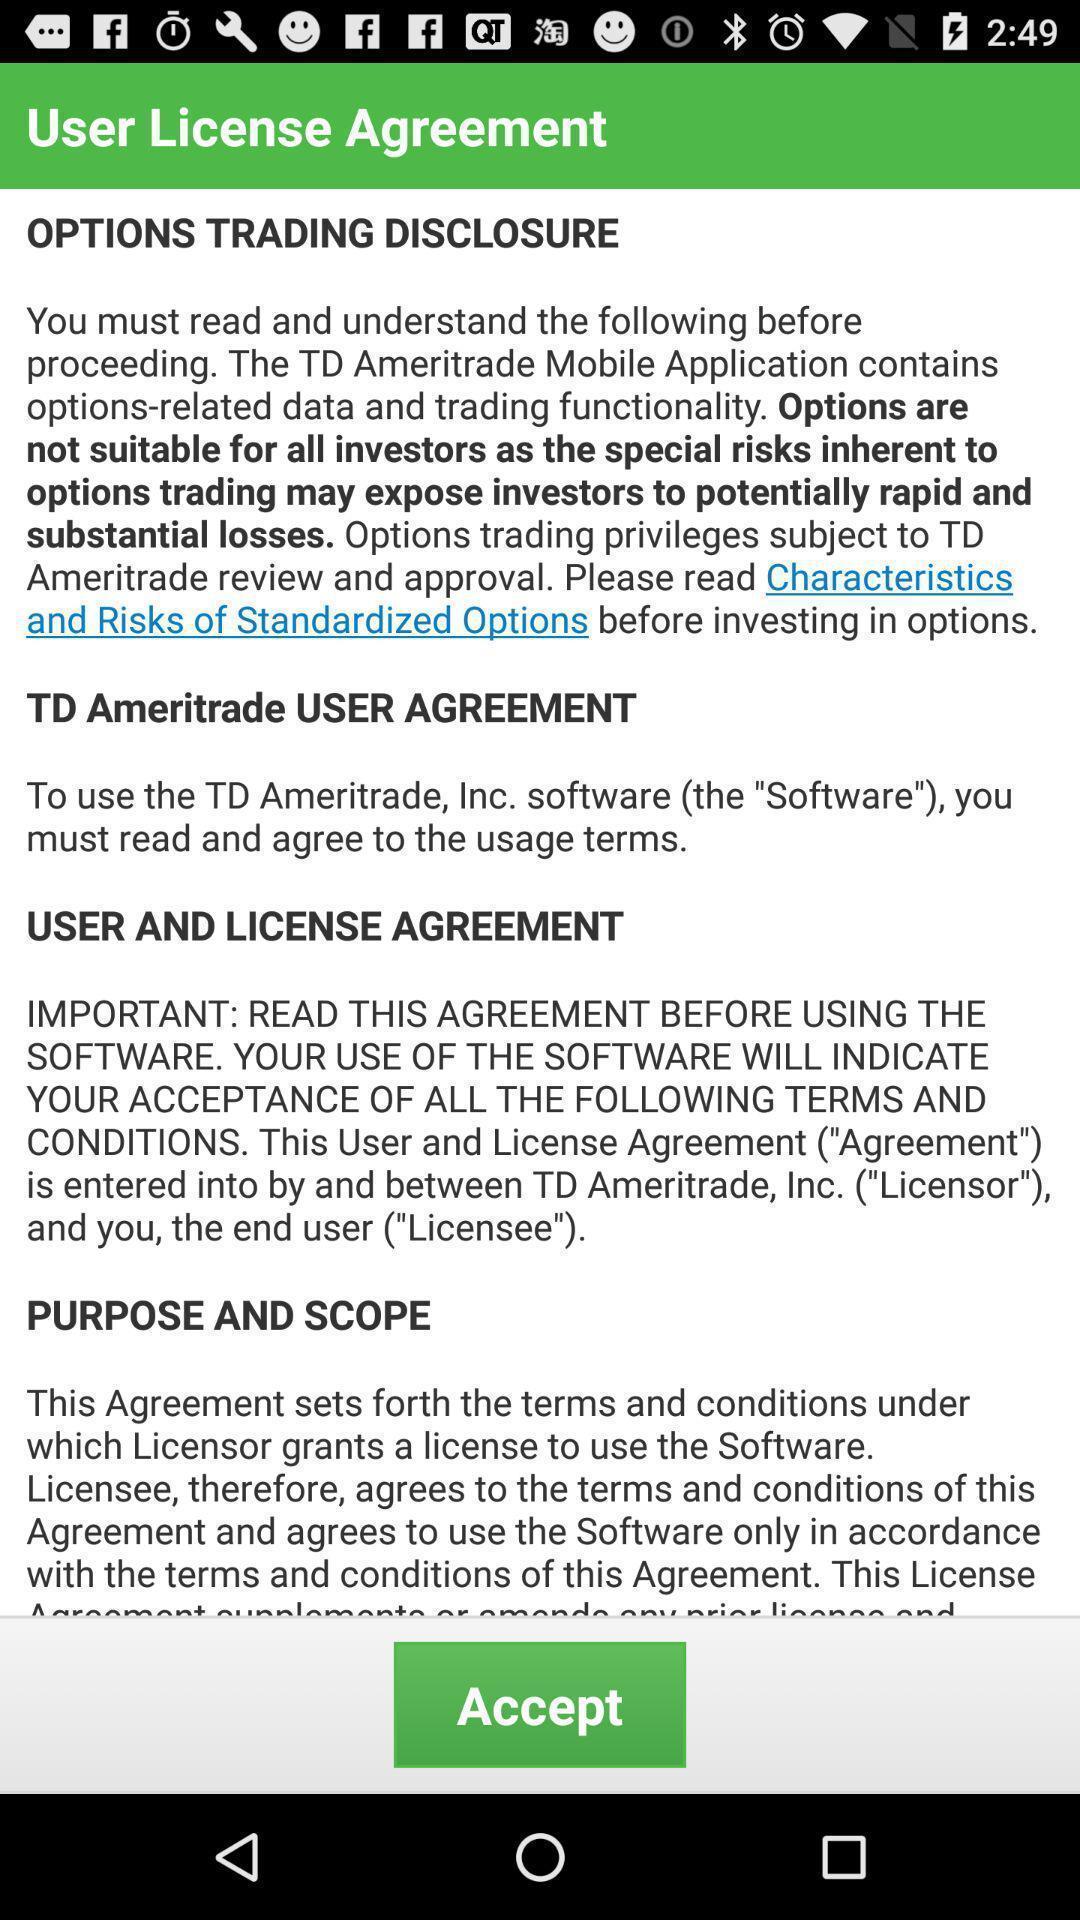Give me a narrative description of this picture. Screen shows user license agreement. 